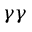<formula> <loc_0><loc_0><loc_500><loc_500>\gamma \gamma</formula> 